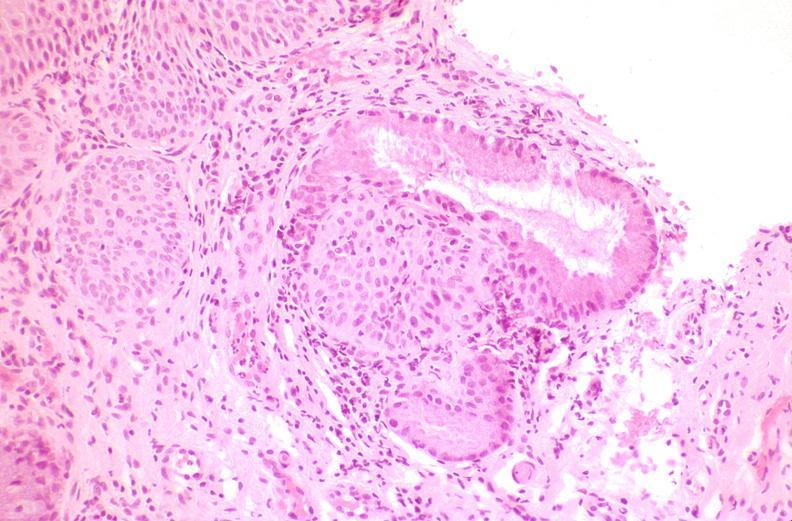does this image show cervix, squamous metaplasia?
Answer the question using a single word or phrase. Yes 